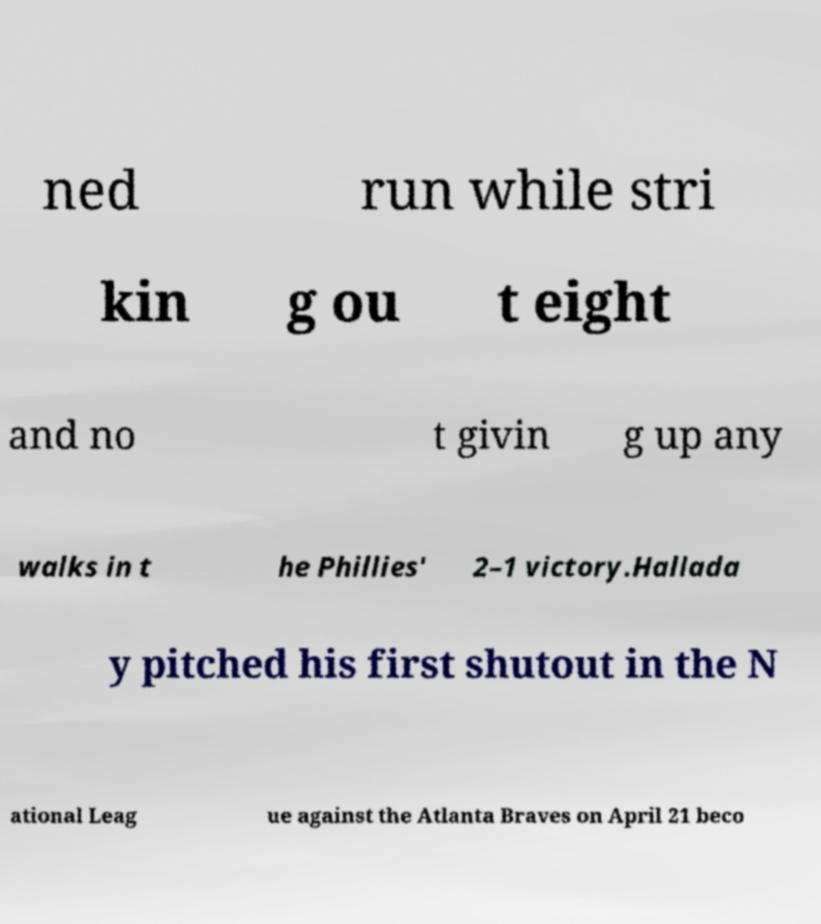Could you assist in decoding the text presented in this image and type it out clearly? ned run while stri kin g ou t eight and no t givin g up any walks in t he Phillies' 2–1 victory.Hallada y pitched his first shutout in the N ational Leag ue against the Atlanta Braves on April 21 beco 